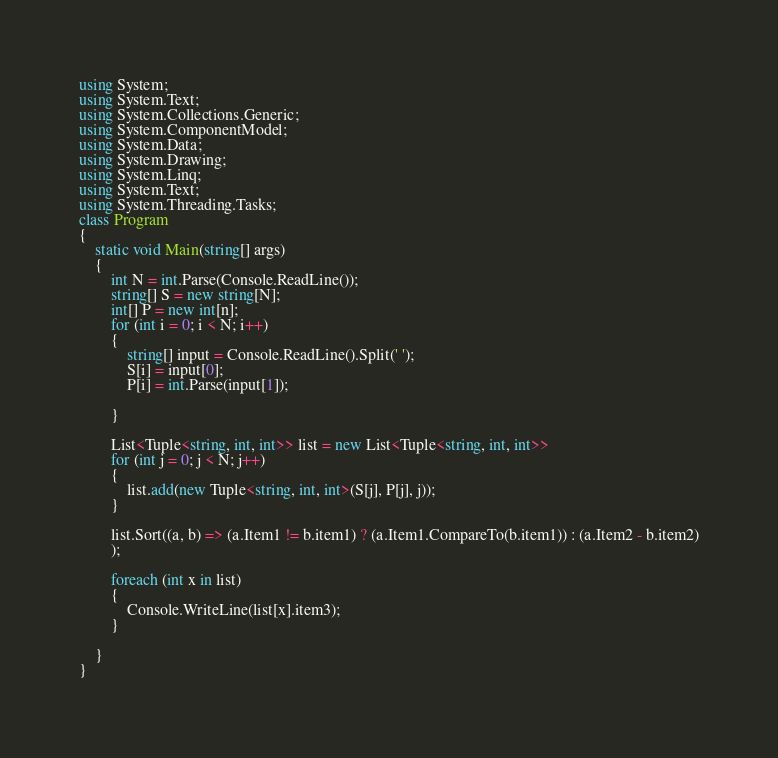Convert code to text. <code><loc_0><loc_0><loc_500><loc_500><_C#_>using System;
using System.Text;
using System.Collections.Generic;
using System.ComponentModel;
using System.Data;
using System.Drawing;
using System.Linq;
using System.Text;
using System.Threading.Tasks;
class Program
{
    static void Main(string[] args)
    {
        int N = int.Parse(Console.ReadLine());
        string[] S = new string[N];
        int[] P = new int[n];
        for (int i = 0; i < N; i++)
        {
            string[] input = Console.ReadLine().Split(' ');
            S[i] = input[0];
            P[i] = int.Parse(input[1]);

        }

        List<Tuple<string, int, int>> list = new List<Tuple<string, int, int>>
        for (int j = 0; j < N; j++)
        {
            list.add(new Tuple<string, int, int>(S[j], P[j], j));
        }

        list.Sort((a, b) => (a.Item1 != b.item1) ? (a.Item1.CompareTo(b.item1)) : (a.Item2 - b.item2)
        );

        foreach (int x in list)
        {
            Console.WriteLine(list[x].item3);
        }

    }
}
</code> 